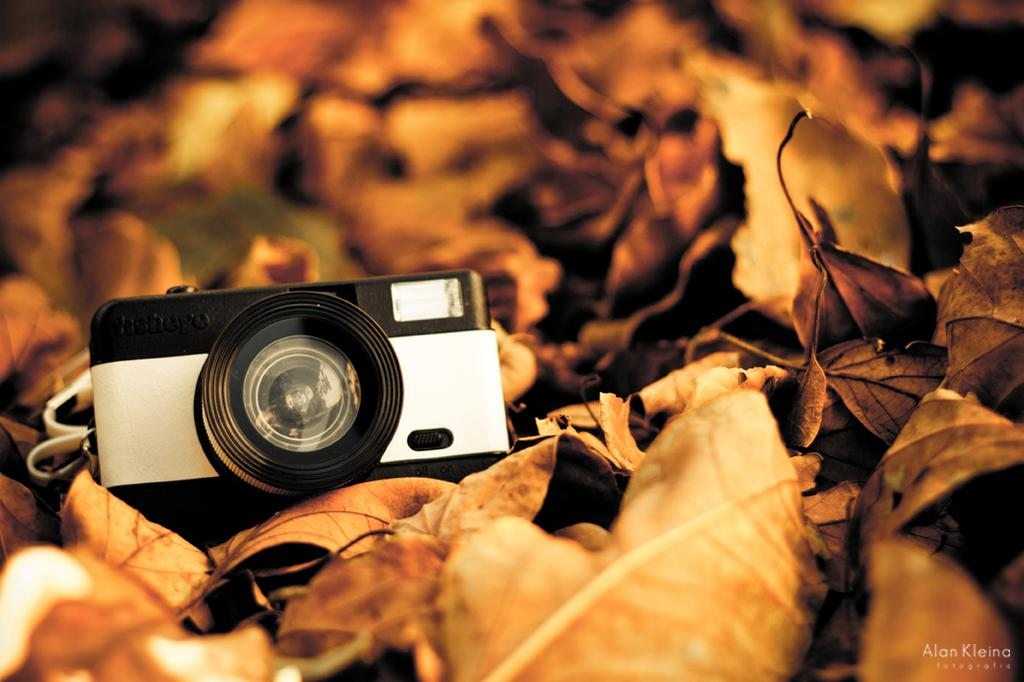What is the main object in the image? There is a camera in the image. What can be seen around the camera? There are dried leaves around the camera. How many apples are being served at the feast in the image? There is no feast or apples present in the image; it features a camera with dried leaves around it. What type of duck can be seen swimming in the water in the image? There is no duck or water present in the image; it features a camera with dried leaves around it. 